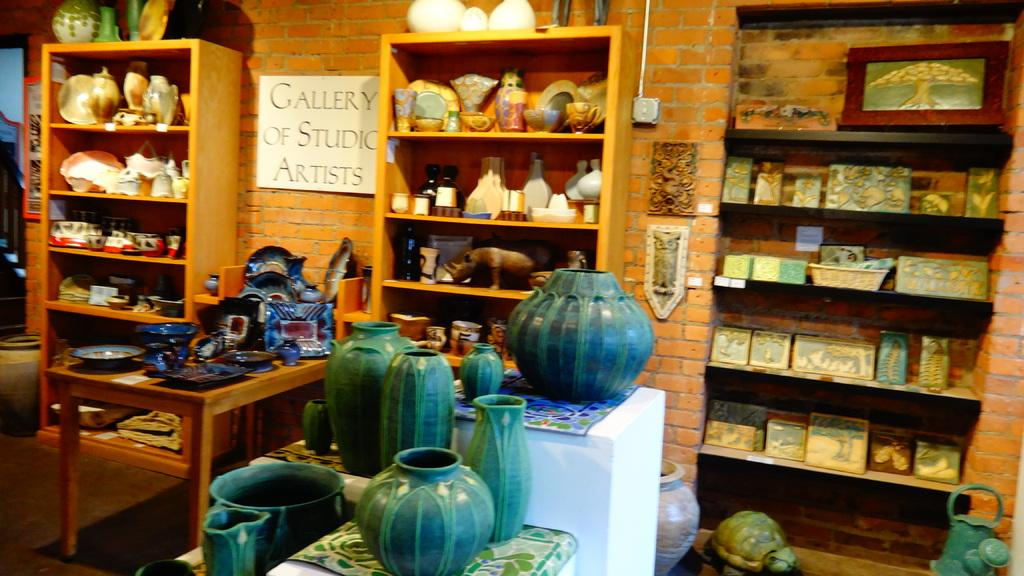<image>
Render a clear and concise summary of the photo. a shop with ceramics and a sign saying Gallery of Studio Artists 